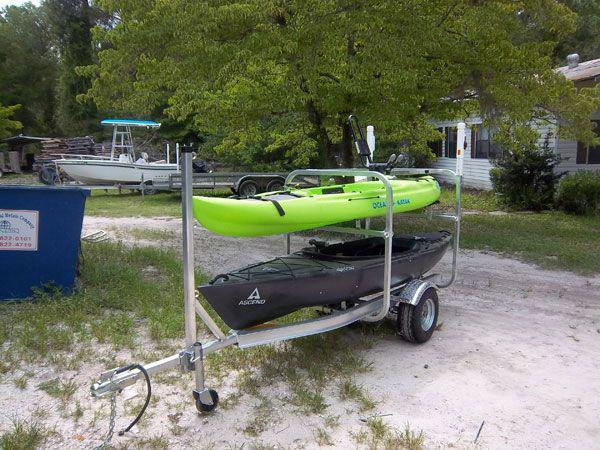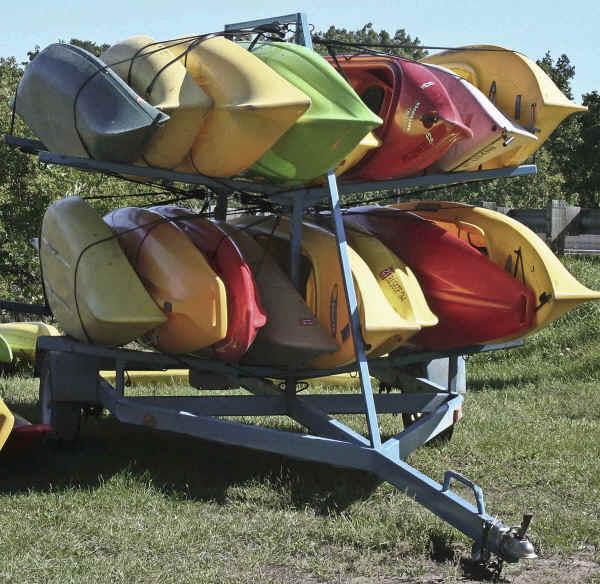The first image is the image on the left, the second image is the image on the right. Given the left and right images, does the statement "At least two of the canoes are green." hold true? Answer yes or no. Yes. 